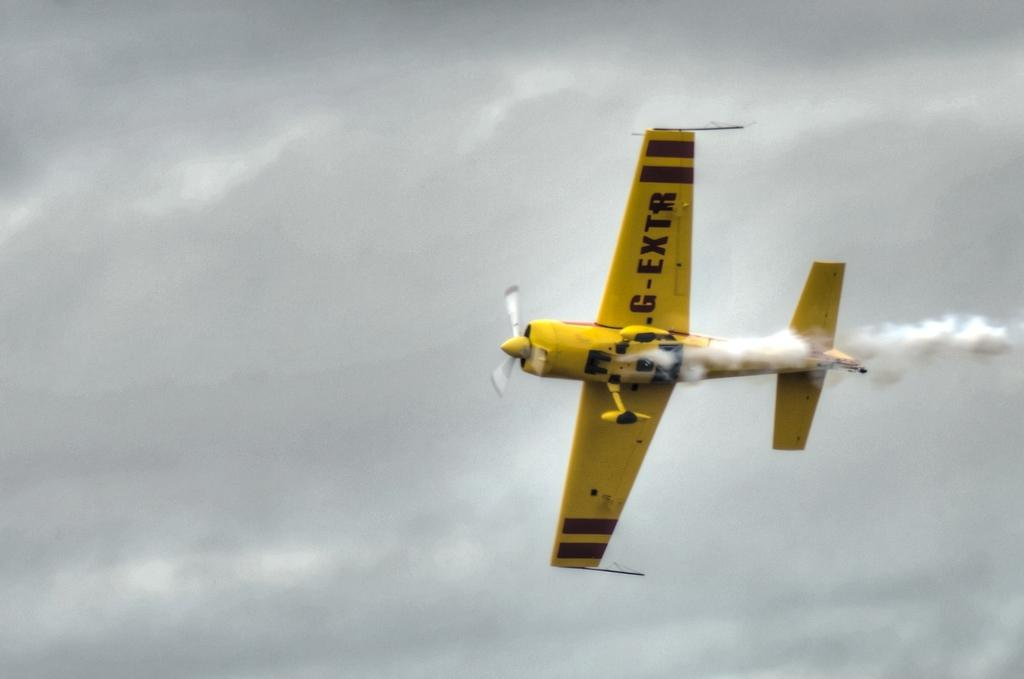Provide a one-sentence caption for the provided image. a yellow prop plane in the air with G-Extr on its wing. 